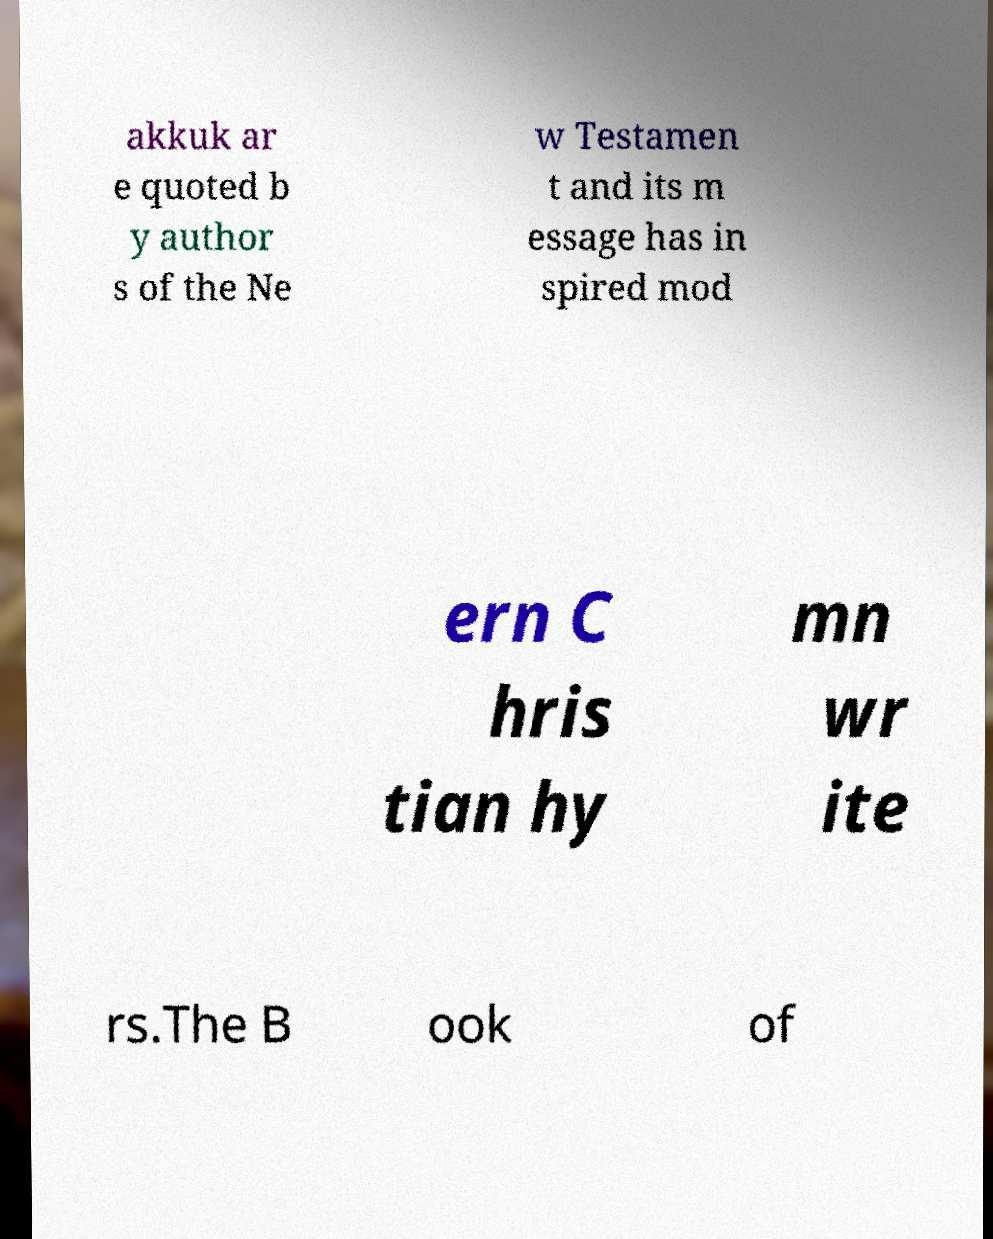Could you assist in decoding the text presented in this image and type it out clearly? akkuk ar e quoted b y author s of the Ne w Testamen t and its m essage has in spired mod ern C hris tian hy mn wr ite rs.The B ook of 